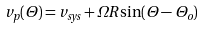<formula> <loc_0><loc_0><loc_500><loc_500>v _ { p } ( \Theta ) = v _ { s y s } + \Omega R \sin ( \Theta - \Theta _ { o } )</formula> 